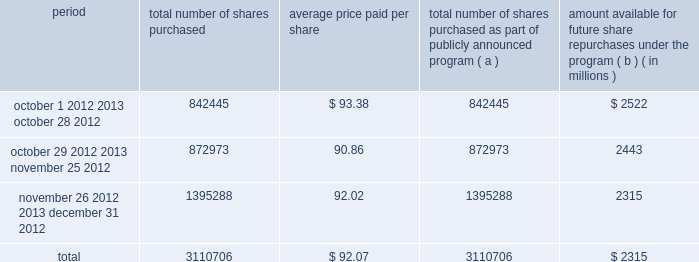Issuer purchases of equity securities the table provides information about our repurchases of common stock during the three-month period ended december 31 , 2012 .
Period total number of shares purchased average price paid per total number of shares purchased as part of publicly announced program ( a ) amount available for future share repurchases the program ( b ) ( in millions ) .
( a ) we repurchased a total of 3.1 million shares of our common stock for $ 286 million during the quarter ended december 31 , 2012 under a share repurchase program that we announced in october 2010 .
( b ) our board of directors has approved a share repurchase program for the repurchase of our common stock from time-to-time , authorizing an amount available for share repurchases of $ 6.5 billion .
Under the program , management has discretion to determine the dollar amount of shares to be repurchased and the timing of any repurchases in compliance with applicable law and regulation .
The program does not have an expiration date .
As of december 31 , 2012 , we had repurchased a total of 54.3 million shares under the program for $ 4.2 billion. .
As of december 31 , 2012 , what was the year to date percent of the share repurchase under the program for $ 4.2 billion..\\n? 
Computations: (4.2 + 54.3)
Answer: 58.5. 